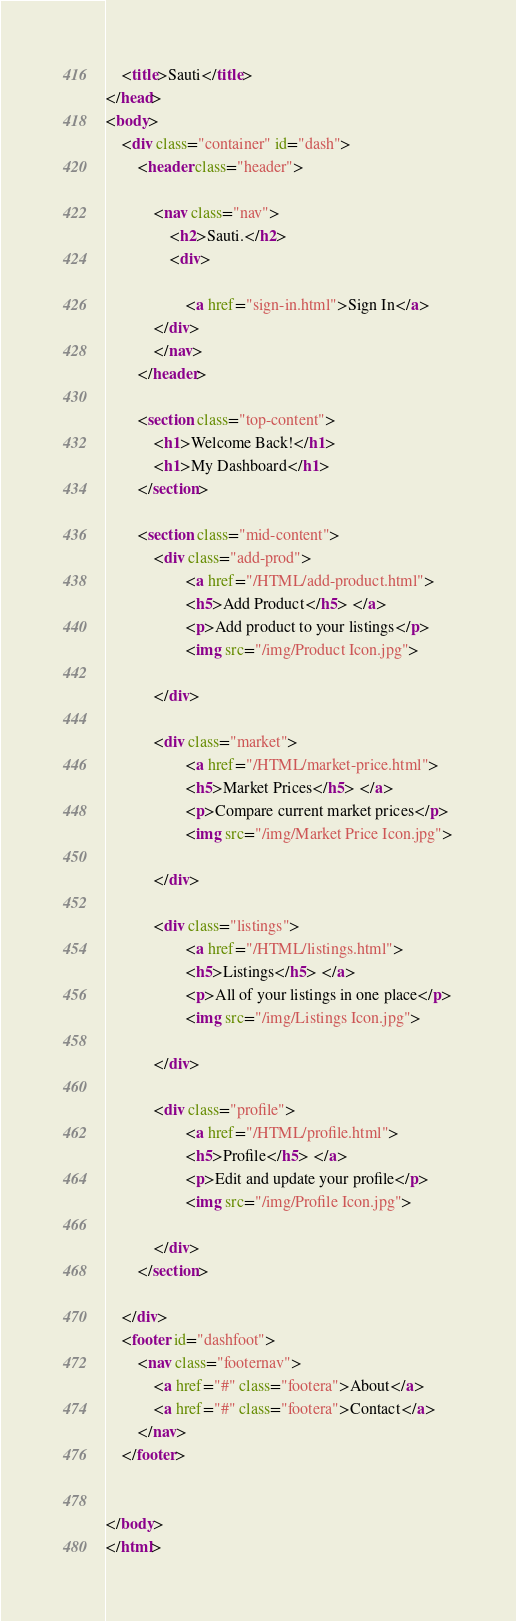<code> <loc_0><loc_0><loc_500><loc_500><_HTML_>    <title>Sauti</title>
</head>
<body>
    <div class="container" id="dash">
        <header class="header">
                
            <nav class="nav">
                <h2>Sauti.</h2>
                <div>
                   
                    <a href="sign-in.html">Sign In</a>
            </div>
            </nav>
        </header>

        <section class="top-content">
            <h1>Welcome Back!</h1>
            <h1>My Dashboard</h1>
        </section>

        <section class="mid-content">
            <div class="add-prod">
                    <a href="/HTML/add-product.html">
                    <h5>Add Product</h5> </a>
                    <p>Add product to your listings</p>
                    <img src="/img/Product Icon.jpg">
                   
            </div>

            <div class="market">
                    <a href="/HTML/market-price.html">
                    <h5>Market Prices</h5> </a>
                    <p>Compare current market prices</p>
                    <img src="/img/Market Price Icon.jpg">
                    
            </div>
        
            <div class="listings">
                    <a href="/HTML/listings.html">
                    <h5>Listings</h5> </a>
                    <p>All of your listings in one place</p>
                    <img src="/img/Listings Icon.jpg">
                   
            </div>

            <div class="profile">
                    <a href="/HTML/profile.html">
                    <h5>Profile</h5> </a>
                    <p>Edit and update your profile</p>
                    <img src="/img/Profile Icon.jpg">
                    
            </div>
        </section>
        
    </div>
    <footer id="dashfoot">
        <nav class="footernav">
            <a href="#" class="footera">About</a>
            <a href="#" class="footera">Contact</a>
        </nav>
    </footer>
   

</body>
</html></code> 